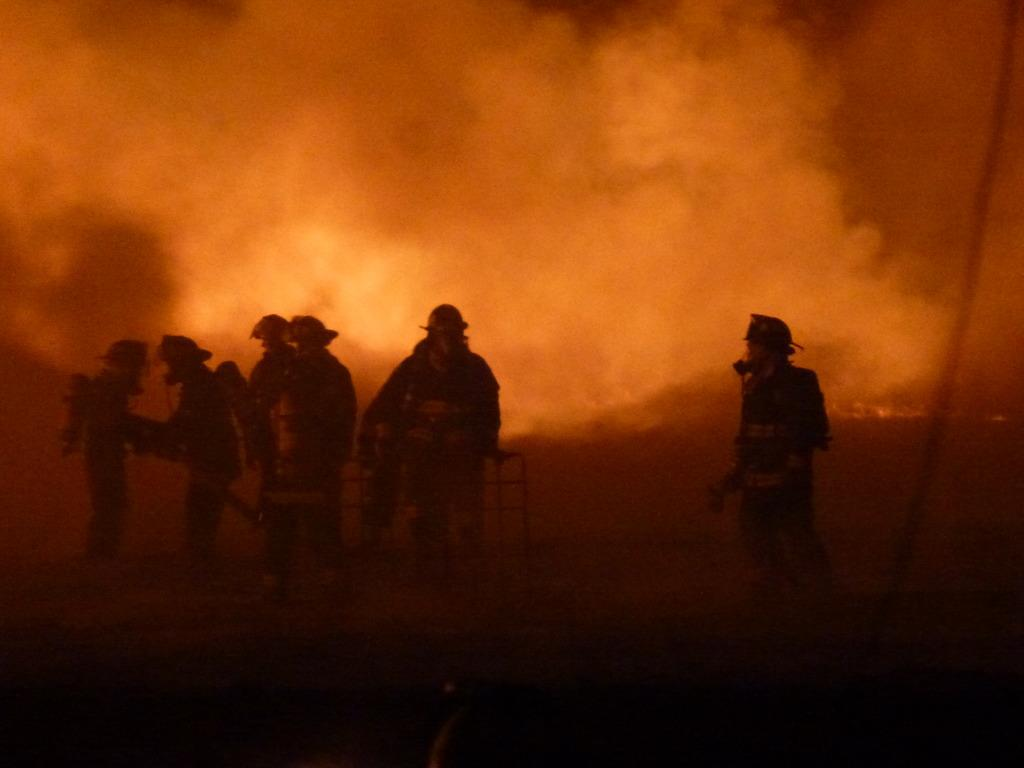What is the overall lighting condition in the image? The image is dark. What can be seen on the ground in the image? There is ground visible in the image, and people are standing on it. What is present in the air in the image? There is smoke visible in the image. What type of stitch is being used by the people on the stage in the image? There is no stage or stitching activity present in the image; it features people standing on the ground with smoke visible in the air. 